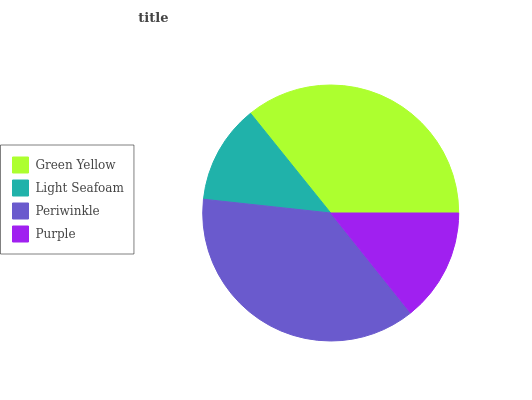Is Light Seafoam the minimum?
Answer yes or no. Yes. Is Periwinkle the maximum?
Answer yes or no. Yes. Is Periwinkle the minimum?
Answer yes or no. No. Is Light Seafoam the maximum?
Answer yes or no. No. Is Periwinkle greater than Light Seafoam?
Answer yes or no. Yes. Is Light Seafoam less than Periwinkle?
Answer yes or no. Yes. Is Light Seafoam greater than Periwinkle?
Answer yes or no. No. Is Periwinkle less than Light Seafoam?
Answer yes or no. No. Is Green Yellow the high median?
Answer yes or no. Yes. Is Purple the low median?
Answer yes or no. Yes. Is Periwinkle the high median?
Answer yes or no. No. Is Light Seafoam the low median?
Answer yes or no. No. 